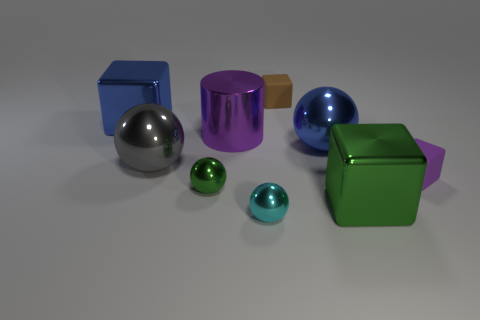Subtract all cylinders. How many objects are left? 8 Add 7 big green things. How many big green things exist? 8 Subtract 1 cyan balls. How many objects are left? 8 Subtract all large green objects. Subtract all big gray things. How many objects are left? 7 Add 1 green balls. How many green balls are left? 2 